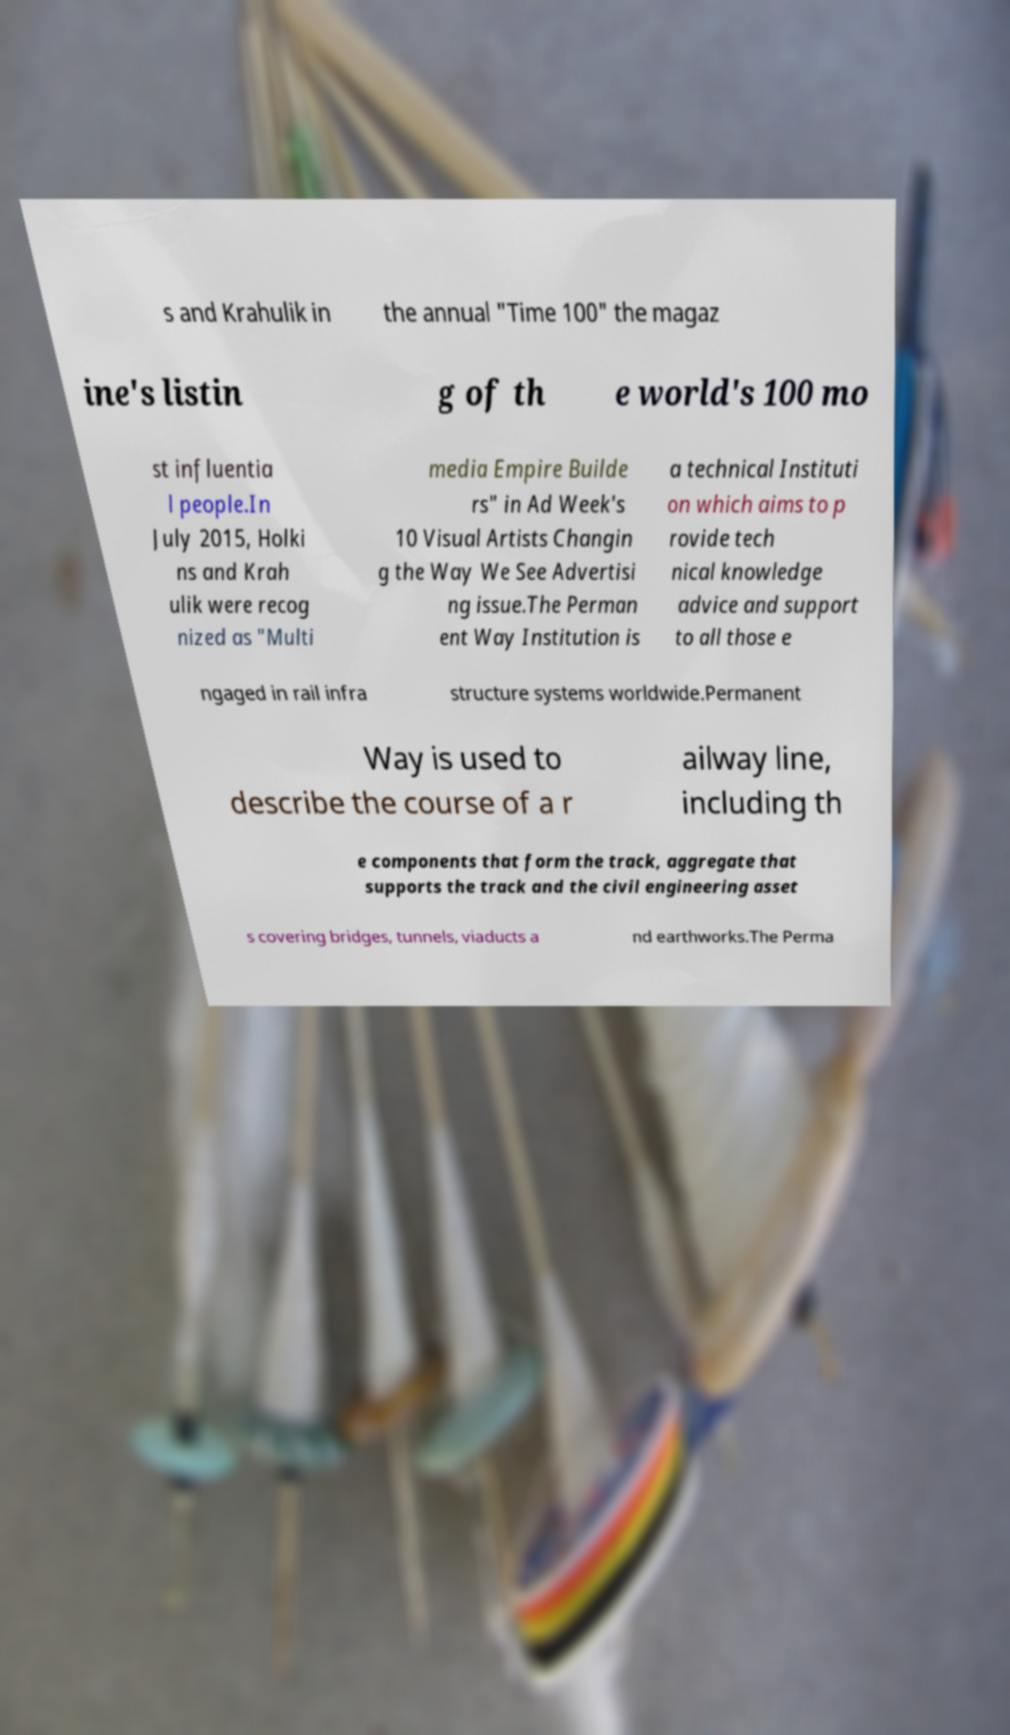There's text embedded in this image that I need extracted. Can you transcribe it verbatim? s and Krahulik in the annual "Time 100" the magaz ine's listin g of th e world's 100 mo st influentia l people.In July 2015, Holki ns and Krah ulik were recog nized as "Multi media Empire Builde rs" in Ad Week's 10 Visual Artists Changin g the Way We See Advertisi ng issue.The Perman ent Way Institution is a technical Instituti on which aims to p rovide tech nical knowledge advice and support to all those e ngaged in rail infra structure systems worldwide.Permanent Way is used to describe the course of a r ailway line, including th e components that form the track, aggregate that supports the track and the civil engineering asset s covering bridges, tunnels, viaducts a nd earthworks.The Perma 